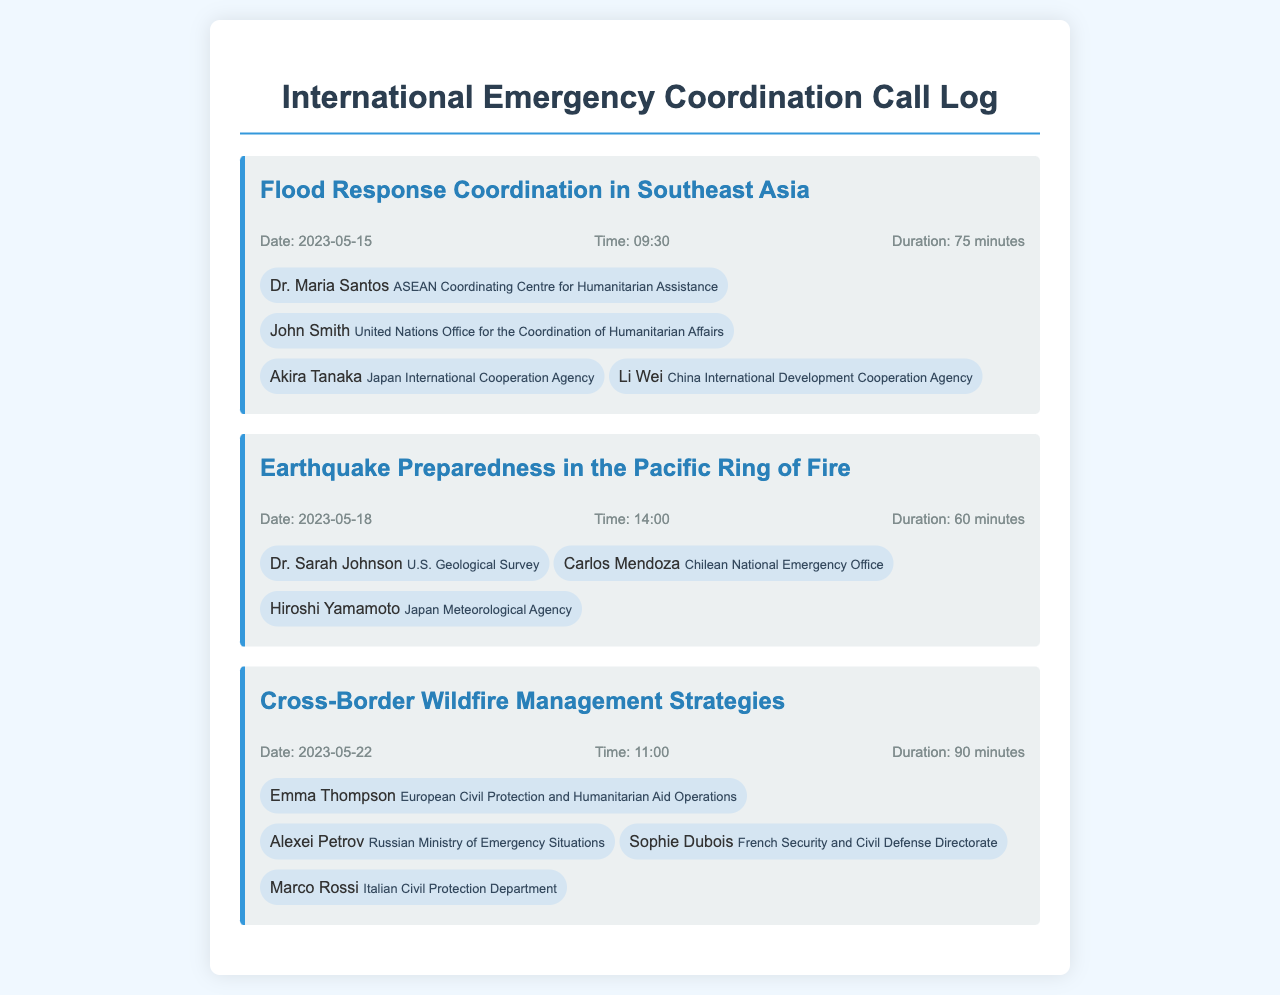what is the duration of the call about Flood Response Coordination? The duration is provided in the document, specifically for the call about Flood Response Coordination, which lasts for 75 minutes.
Answer: 75 minutes who participated in the Earthquake Preparedness call? The participants listed are Dr. Sarah Johnson, Carlos Mendoza, and Hiroshi Yamamoto, as detailed in the call entry for Earthquake Preparedness.
Answer: Dr. Sarah Johnson, Carlos Mendoza, Hiroshi Yamamoto how many participants were involved in the Cross-Border Wildfire Management call? The document mentions four participants in the Cross-Border Wildfire Management call entry.
Answer: 4 participants what was the date of the Flood Response Coordination meeting? The date specified in the document for the Flood Response Coordination meeting is May 15, 2023.
Answer: 2023-05-15 which organization is Akira Tanaka affiliated with? The document states that Akira Tanaka is affiliated with the Japan International Cooperation Agency.
Answer: Japan International Cooperation Agency which call had the longest duration? By comparing the durations provided in the document, the call about Cross-Border Wildfire Management had the longest duration at 90 minutes.
Answer: Cross-Border Wildfire Management what time did the Earthquake Preparedness call start? The document indicates that the Earthquake Preparedness call started at 14:00.
Answer: 14:00 who is associated with the United Nations Office for the Coordination of Humanitarian Affairs? The participant associated with that organization is John Smith, as stated in the call log.
Answer: John Smith 